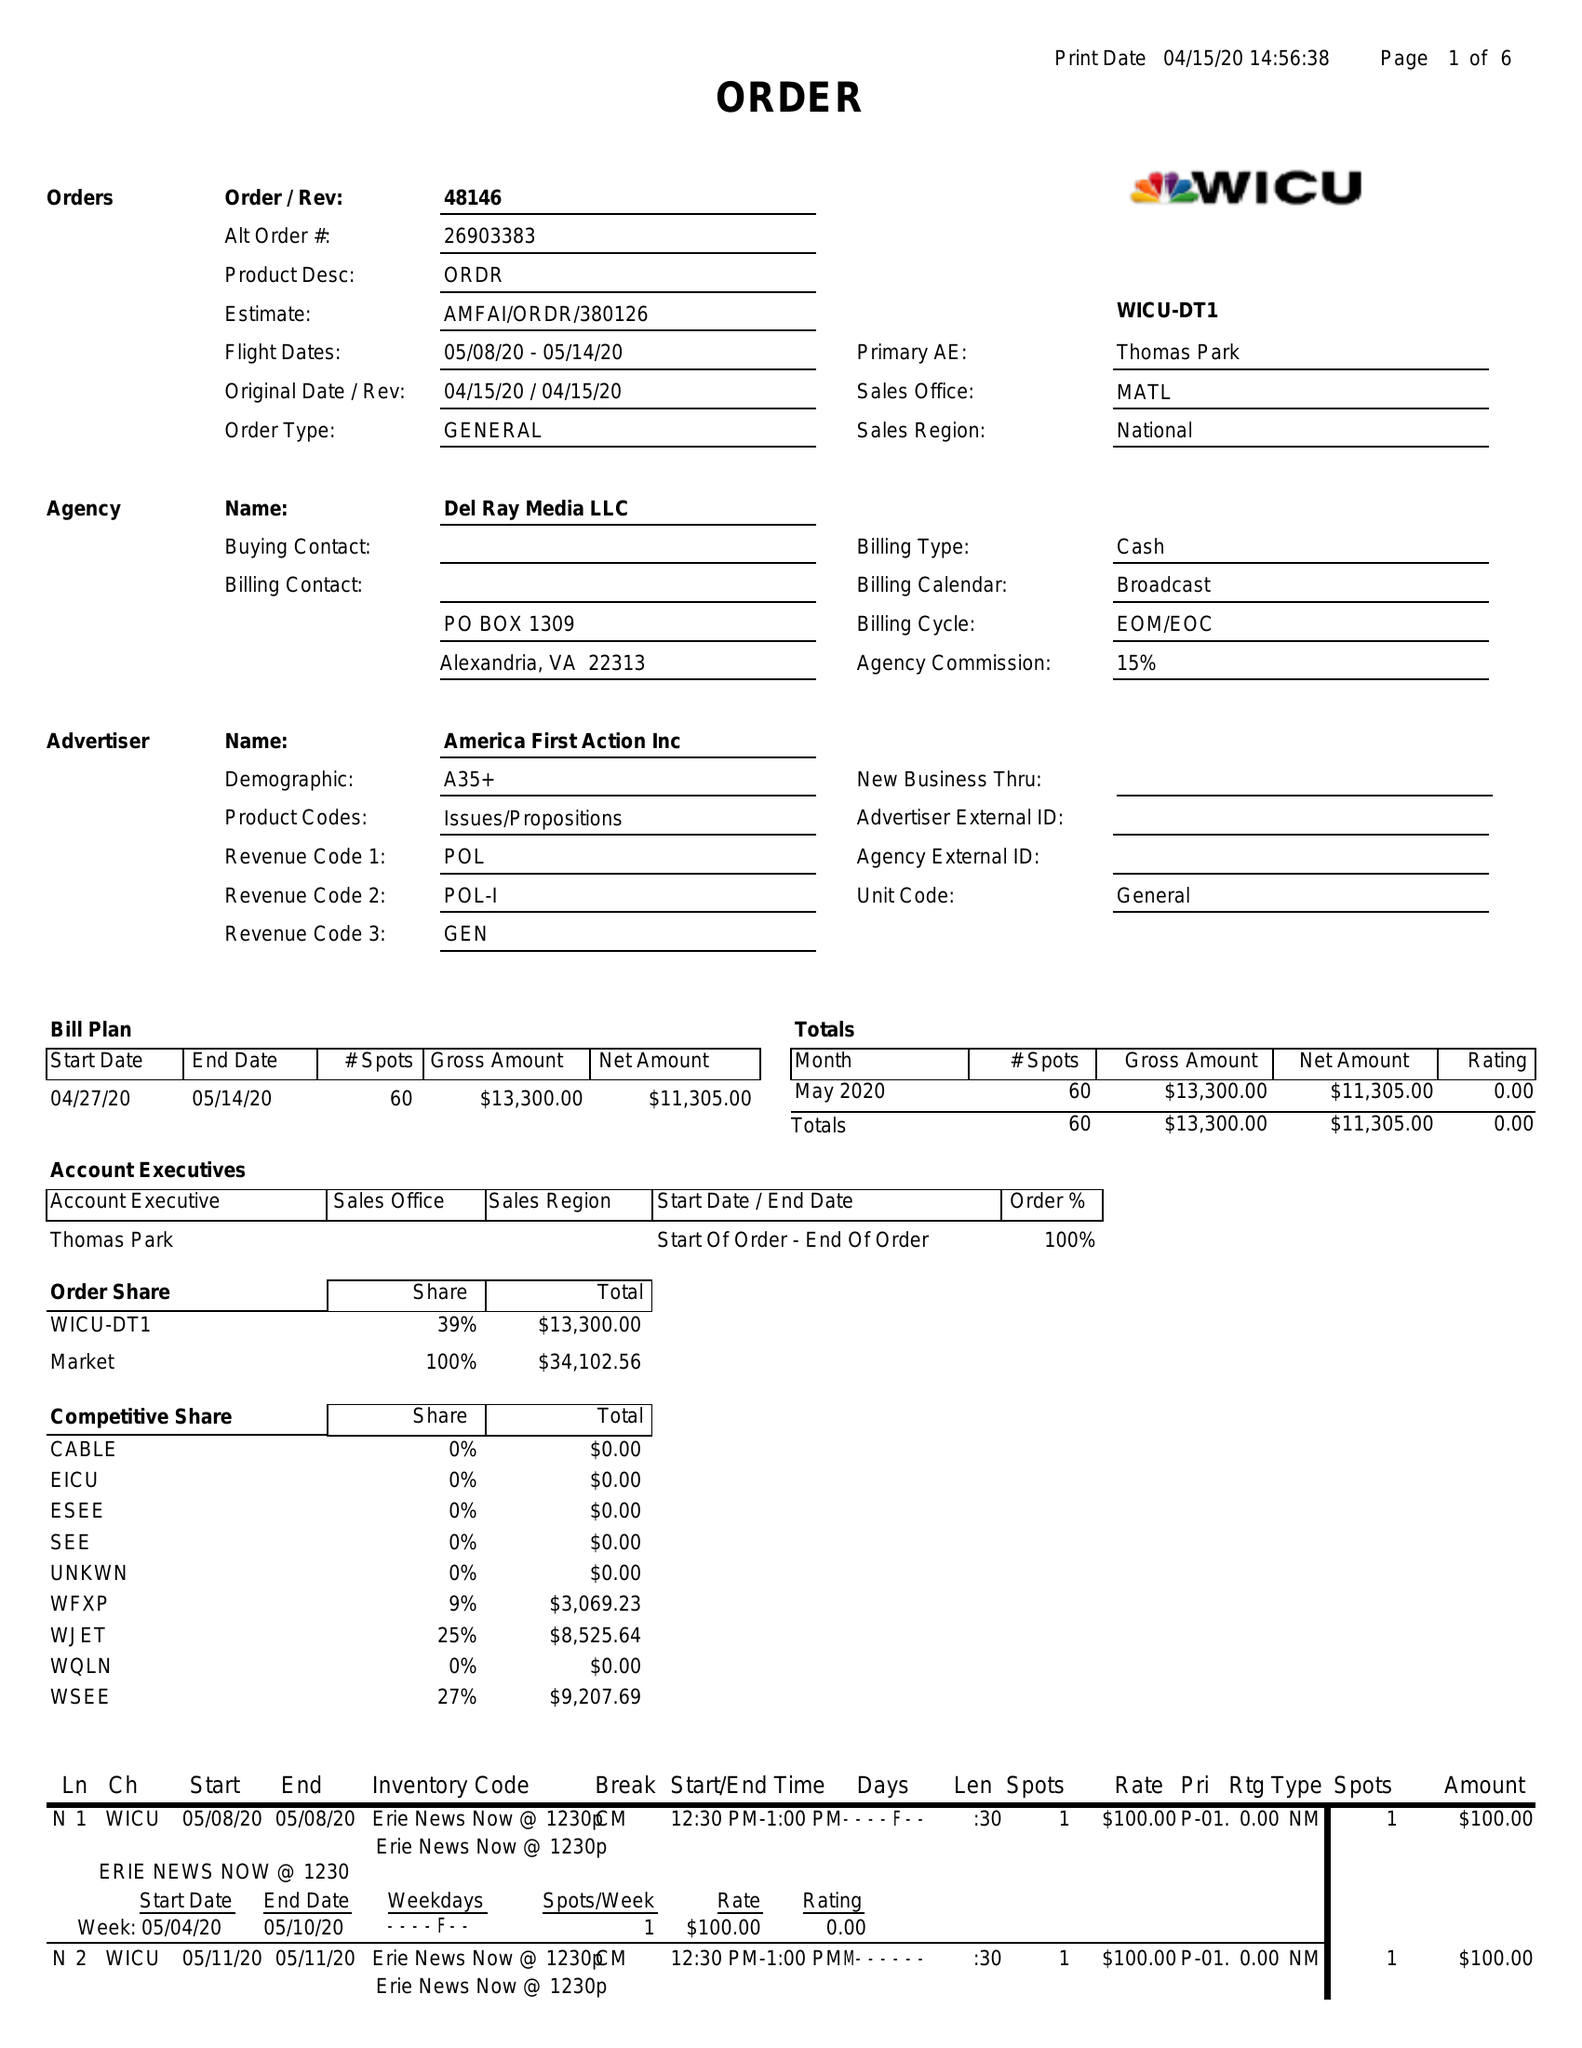What is the value for the gross_amount?
Answer the question using a single word or phrase. 13300.00 